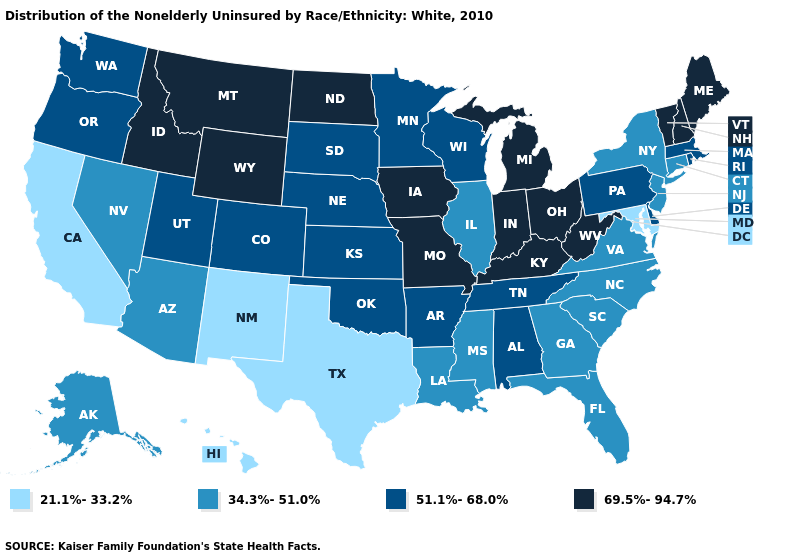What is the value of New York?
Write a very short answer. 34.3%-51.0%. Which states have the lowest value in the USA?
Short answer required. California, Hawaii, Maryland, New Mexico, Texas. What is the highest value in the West ?
Give a very brief answer. 69.5%-94.7%. Does Texas have the lowest value in the USA?
Write a very short answer. Yes. Is the legend a continuous bar?
Quick response, please. No. Does Maryland have a lower value than Alaska?
Short answer required. Yes. What is the lowest value in states that border Virginia?
Concise answer only. 21.1%-33.2%. Name the states that have a value in the range 21.1%-33.2%?
Be succinct. California, Hawaii, Maryland, New Mexico, Texas. Does the map have missing data?
Short answer required. No. Name the states that have a value in the range 51.1%-68.0%?
Concise answer only. Alabama, Arkansas, Colorado, Delaware, Kansas, Massachusetts, Minnesota, Nebraska, Oklahoma, Oregon, Pennsylvania, Rhode Island, South Dakota, Tennessee, Utah, Washington, Wisconsin. Does South Dakota have the same value as Oregon?
Give a very brief answer. Yes. Among the states that border Oklahoma , does Missouri have the lowest value?
Be succinct. No. Which states have the highest value in the USA?
Keep it brief. Idaho, Indiana, Iowa, Kentucky, Maine, Michigan, Missouri, Montana, New Hampshire, North Dakota, Ohio, Vermont, West Virginia, Wyoming. Name the states that have a value in the range 69.5%-94.7%?
Concise answer only. Idaho, Indiana, Iowa, Kentucky, Maine, Michigan, Missouri, Montana, New Hampshire, North Dakota, Ohio, Vermont, West Virginia, Wyoming. 